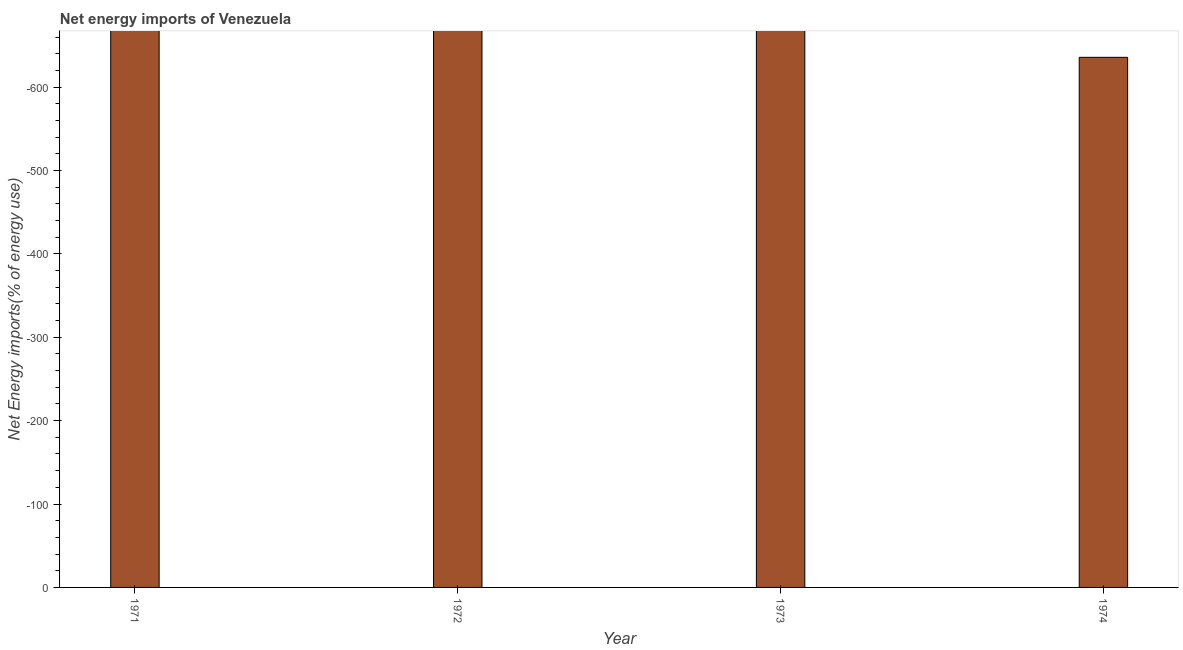Does the graph contain any zero values?
Your answer should be very brief. Yes. What is the title of the graph?
Provide a succinct answer. Net energy imports of Venezuela. What is the label or title of the Y-axis?
Make the answer very short. Net Energy imports(% of energy use). In how many years, is the energy imports greater than -400 %?
Keep it short and to the point. 0. In how many years, is the energy imports greater than the average energy imports taken over all years?
Provide a succinct answer. 0. How many bars are there?
Keep it short and to the point. 0. How many years are there in the graph?
Your response must be concise. 4. What is the difference between two consecutive major ticks on the Y-axis?
Give a very brief answer. 100. Are the values on the major ticks of Y-axis written in scientific E-notation?
Provide a succinct answer. No. What is the Net Energy imports(% of energy use) of 1972?
Your response must be concise. 0. What is the Net Energy imports(% of energy use) of 1973?
Make the answer very short. 0. What is the Net Energy imports(% of energy use) of 1974?
Ensure brevity in your answer.  0. 